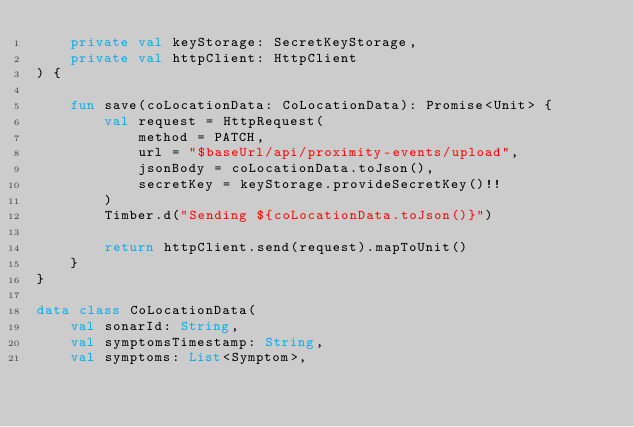Convert code to text. <code><loc_0><loc_0><loc_500><loc_500><_Kotlin_>    private val keyStorage: SecretKeyStorage,
    private val httpClient: HttpClient
) {

    fun save(coLocationData: CoLocationData): Promise<Unit> {
        val request = HttpRequest(
            method = PATCH,
            url = "$baseUrl/api/proximity-events/upload",
            jsonBody = coLocationData.toJson(),
            secretKey = keyStorage.provideSecretKey()!!
        )
        Timber.d("Sending ${coLocationData.toJson()}")

        return httpClient.send(request).mapToUnit()
    }
}

data class CoLocationData(
    val sonarId: String,
    val symptomsTimestamp: String,
    val symptoms: List<Symptom>,</code> 